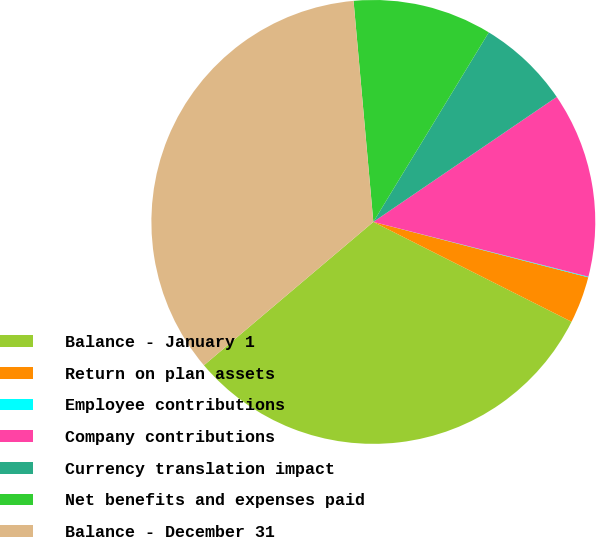Convert chart to OTSL. <chart><loc_0><loc_0><loc_500><loc_500><pie_chart><fcel>Balance - January 1<fcel>Return on plan assets<fcel>Employee contributions<fcel>Company contributions<fcel>Currency translation impact<fcel>Net benefits and expenses paid<fcel>Balance - December 31<nl><fcel>31.4%<fcel>3.41%<fcel>0.05%<fcel>13.49%<fcel>6.77%<fcel>10.13%<fcel>34.76%<nl></chart> 